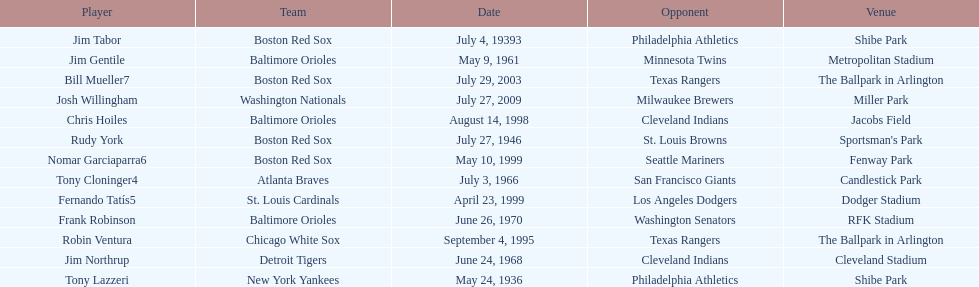What was the name of the last person to accomplish this up to date? Josh Willingham. 